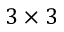<formula> <loc_0><loc_0><loc_500><loc_500>3 \times 3</formula> 